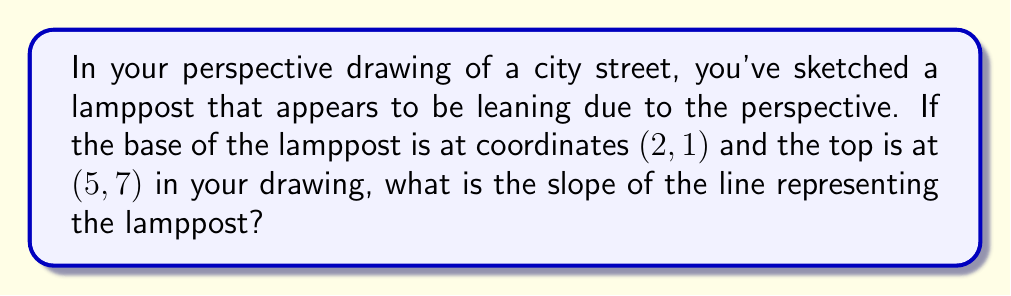Can you answer this question? Let's approach this step-by-step:

1) The slope of a line can be calculated using the formula:

   $$m = \frac{y_2 - y_1}{x_2 - x_1}$$

   Where $(x_1, y_1)$ is the first point and $(x_2, y_2)$ is the second point.

2) In this case:
   - The base of the lamppost is at $(x_1, y_1) = (2, 1)$
   - The top of the lamppost is at $(x_2, y_2) = (5, 7)$

3) Let's substitute these values into our formula:

   $$m = \frac{7 - 1}{5 - 2}$$

4) Simplify:
   $$m = \frac{6}{3}$$

5) Reduce the fraction:
   $$m = 2$$

Therefore, the slope of the line representing the lamppost in your perspective drawing is 2.
Answer: $2$ 